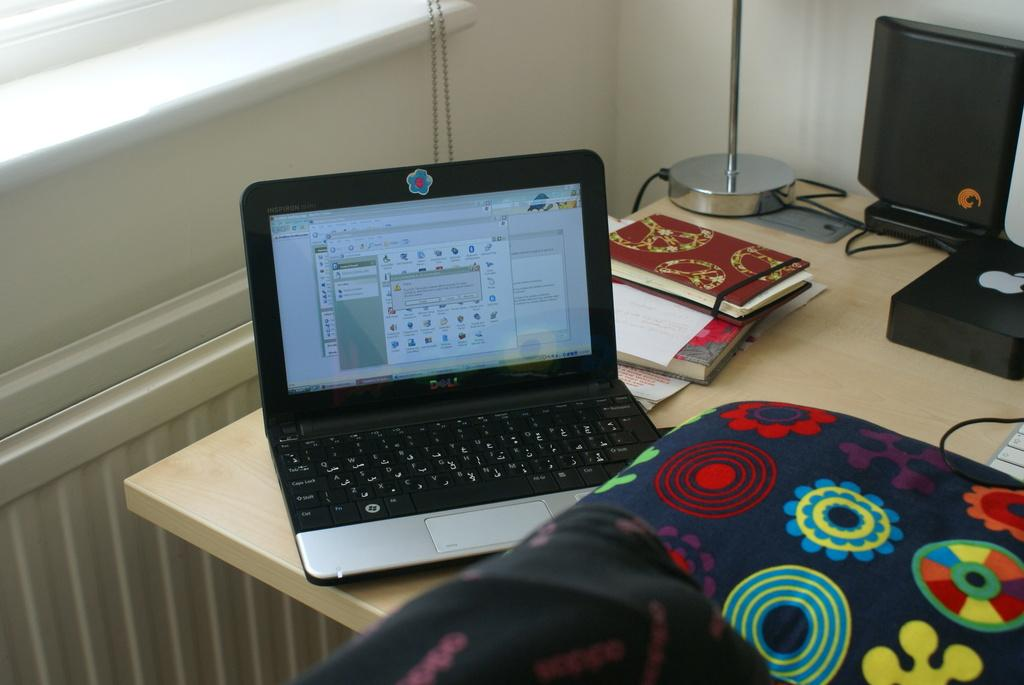What type of furniture is present in the image? There is a table in the image. What is on top of the table? There is a screen and a book on the table. Are there any other items on the table? Yes, there are other unspecified things on the table. What type of cave is visible in the image? There is no cave present in the image; it features a table with a screen, a book, and other unspecified items. 